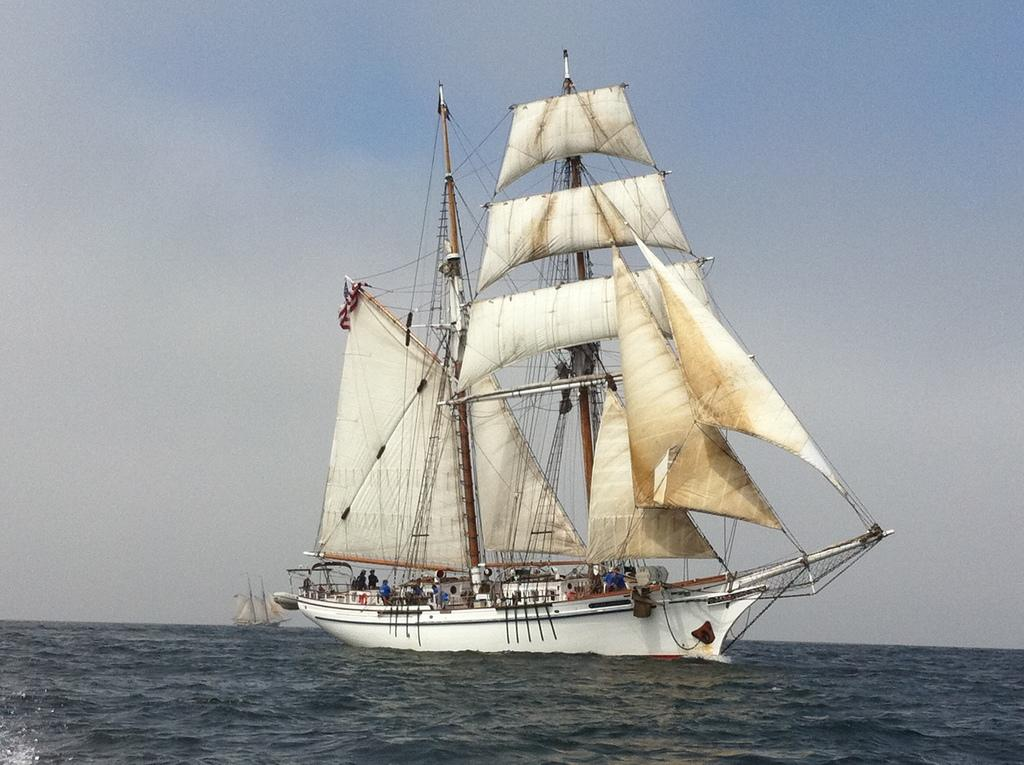What is the main subject of the image? The main subject of the image is ships. Where are the ships located? The ships are on the water. Are there any people present in the image? Yes, there are people in the ships. What type of twig can be seen in the image? There is no twig present in the image; it features ships on the water with people in them. What kind of apparel are the people wearing in the image? The facts provided do not mention the apparel of the people in the image. --- Facts: 1. There is a car in the image. 2. The car is parked on the street. 3. There are trees in the background. 4. The sky is visible in the image. Absurd Topics: parrot, sand, tent Conversation: What is the main subject of the image? The main subject of the image is a car. Where is the car located? The car is parked on the street. What can be seen in the background of the image? There are trees in the background. What is visible at the top of the image? The sky is visible in the image. Reasoning: Let's think step by step in order to produce the conversation. We start by identifying the main subject of the image, which is the car. Then, we describe its location, which is parked on the street. Next, we mention the presence of trees in the background and the sky visible at the top of the image. Absurd Question/Answer: Can you tell me how many parrots are sitting on the car in the image? There are no parrots present in the image; it features a car parked on the street with trees in the background and the sky visible. Is there a tent set up next to the car in the image? There is no tent present in the image; it only features a car parked on the street with trees in the background and the sky visible. 